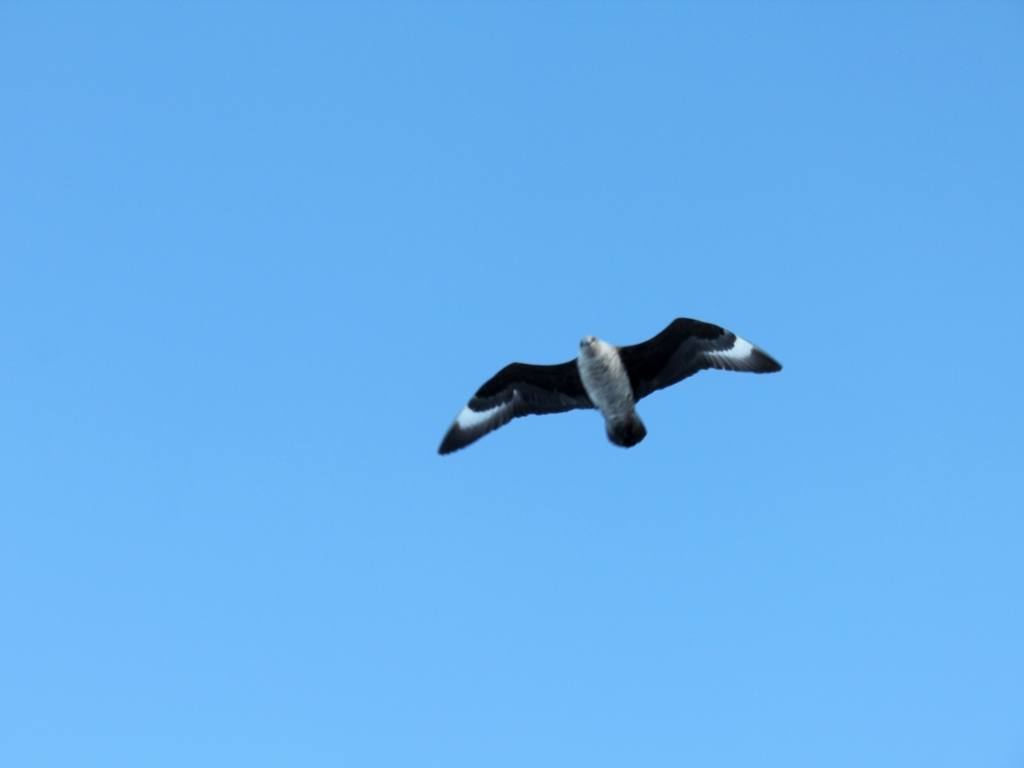Can you tell anything about the bird's behavior from this image? The bird is captured with its wings fully extended in a gliding position, which is typical behavior for seabirds that utilize air currents above the sea to conserve energy while searching for food or during migration. Is there anything that indicates the habitat or geographical location from this image? While the clear blue sky doesn't provide specific details about the habitat or geographical location, the bird's characteristics suggest it might be found in coastal or open ocean environments where such seabirds are often observed. 